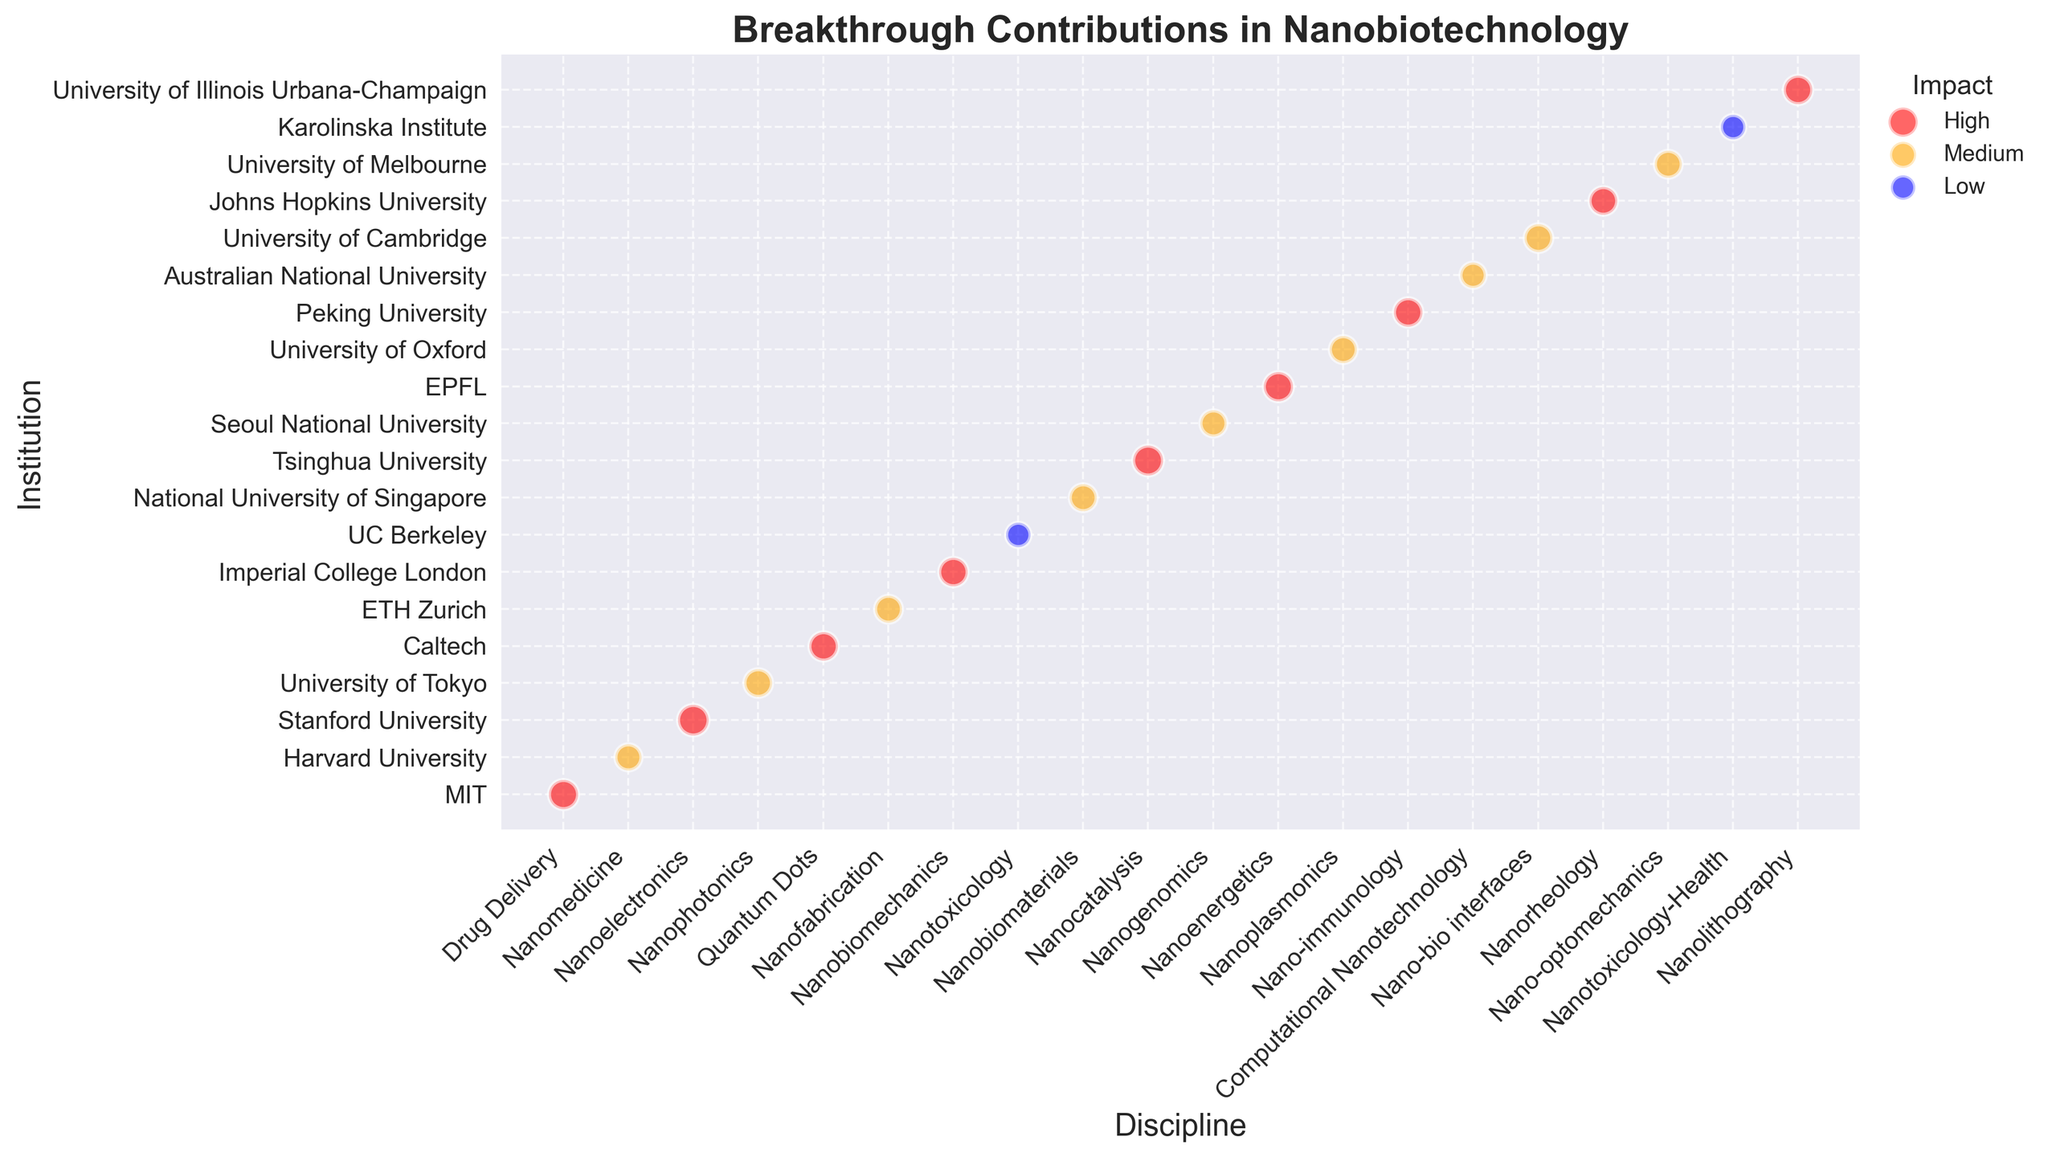Which institution's contribution in the "Nanomedicine" discipline has a "Medium" impact? Look for the discipline "Nanomedicine" and check the impact of the contribution. The institution listed with "Medium" impact under "Nanomedicine" is Harvard University.
Answer: Harvard University How many institutions have contributions with a "High" impact? Count the number of institutions whose contributions are marked with a "High" impact. There are 10 institutions with a "High" impact contribution.
Answer: 10 What is the size of the contributions made by MIT in the "Drug Delivery" discipline? Locate the contribution by MIT in the "Drug Delivery" discipline and note its size. The size of MIT's contribution is 100.
Answer: 100 Which discipline has the largest contribution size from Stanford University? Identify the disciplines contributed by Stanford University and compare the sizes to find the largest. Stanford University has a single contribution in "Nanoelectronics" with a size of 110, which is the largest.
Answer: Nanoelectronics What is the difference in impact levels between the contributions from the University of Tokyo and ETH Zurich? Compare the impact levels of contributions from the University of Tokyo (Medium) and ETH Zurich (Medium). Both have the same impact level, "Medium", so the difference is 0.
Answer: 0 Which disciplines do institutions with contributions of size 85 belong to? Find all contributions having a size of 85 and list the corresponding disciplines. The disciplines are "Nanofabrication", "Nanobiomaterials", "Nanoplasmonics", "Nano-optomechanics".
Answer: Nanofabrication, Nanobiomaterials, Nanoplasmonics, Nano-optomechanics Which institution has a contribution in the "Quantum Dots" discipline, and what is the size of this contribution? Locate the "Quantum Dots" discipline and check which institution has contributed to it and note the size. The contribution in "Quantum Dots" comes from Caltech with a size of 95.
Answer: Caltech, 95 Which contributions from different disciplines have the same "High" impact and the same size of 95? Find contributions with a "High" impact and check if any of them have the same size of 95. The contributions with these criteria are from "Quantum Dots" (Caltech), "Nanobiomechanics" (Imperial College London), "Nano-immunology" (Peking University), and "Nanolithography" (University of Illinois Urbana-Champaign).
Answer: Quantum Dots, Nanobiomechanics, Nano-immunology, Nanolithography Between "Nanoelectonics" and "Nanoenergetics", which discipline has a higher size of contribution from its respective institution? Compare the size of contributions in "Nanoelectronics" (Stanford University) and "Nanoenergetics" (EPFL). "Nanoelectronics" has a contribution size of 110, whereas "Nanoenergetics" has a size of 100. Therefore, "Nanoelectronics" has a higher size.
Answer: Nanoelectronics 